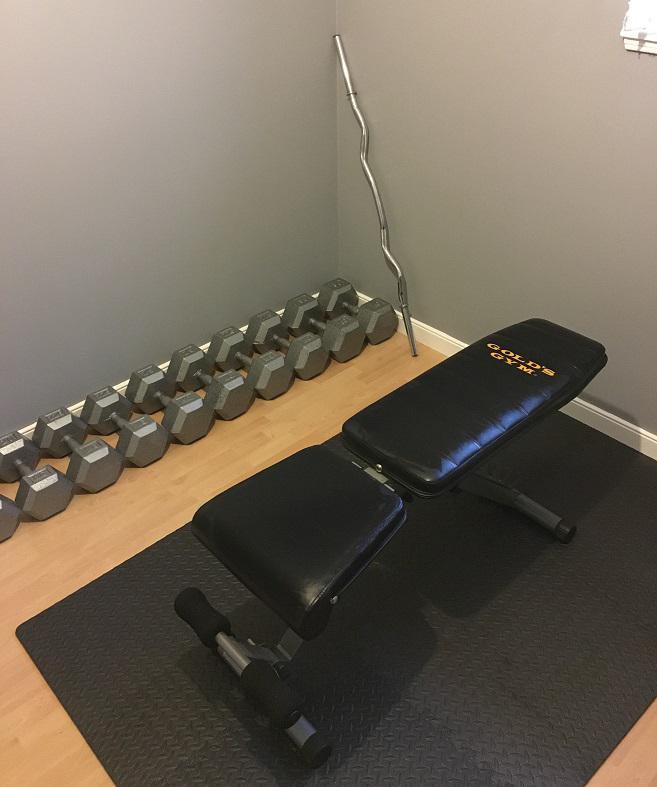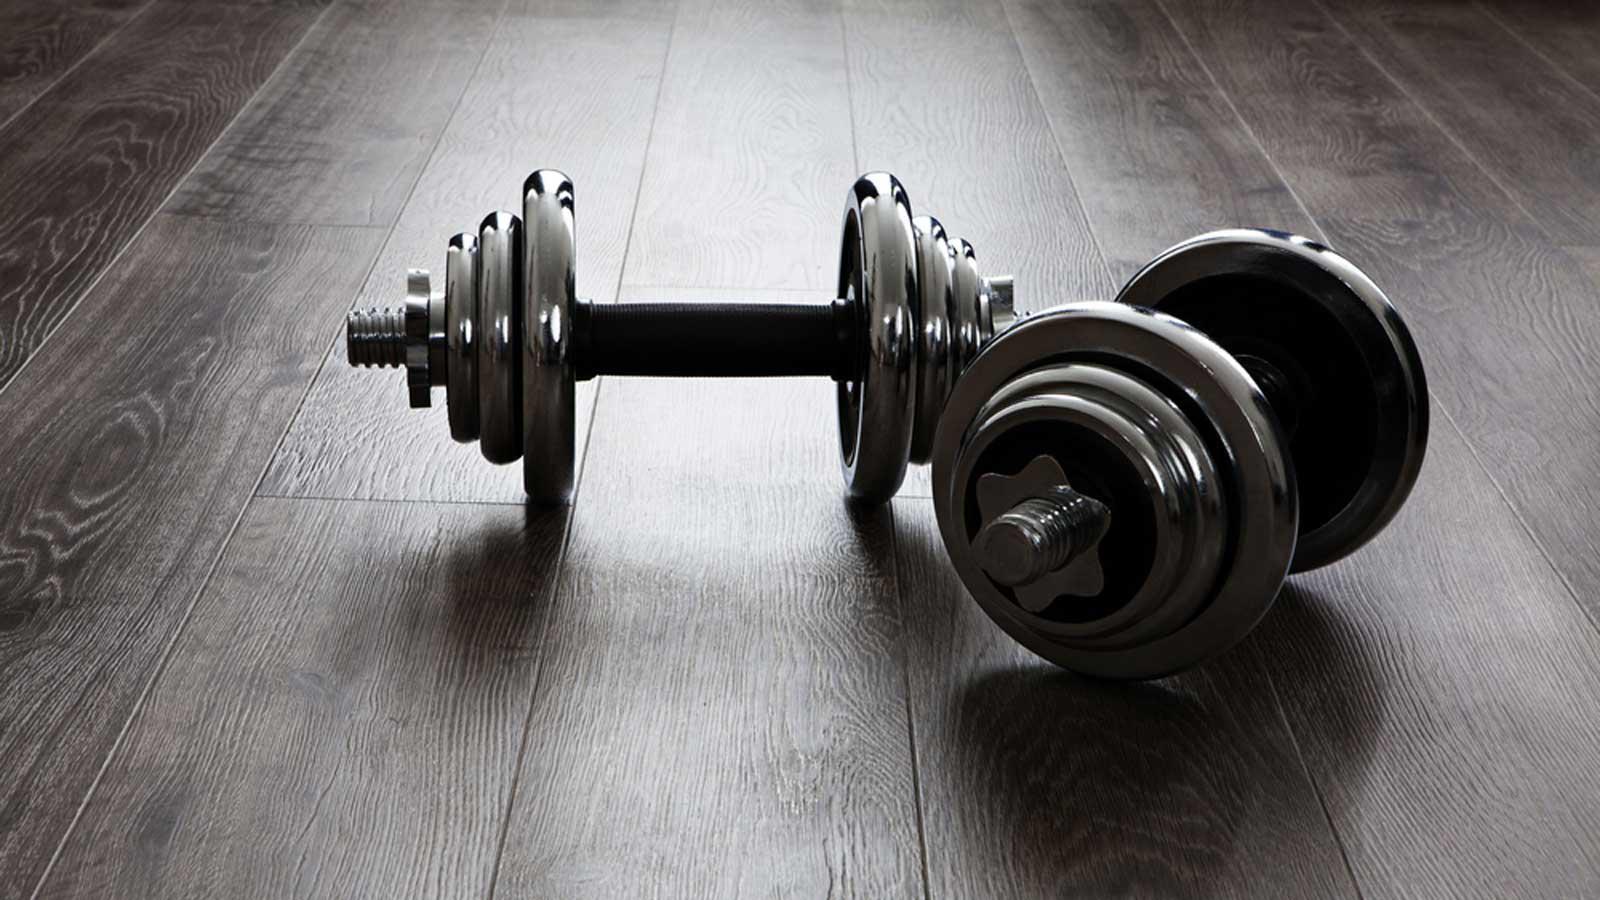The first image is the image on the left, the second image is the image on the right. Evaluate the accuracy of this statement regarding the images: "In at least one image there is a person sitting and working out with weights.". Is it true? Answer yes or no. No. The first image is the image on the left, the second image is the image on the right. Given the left and right images, does the statement "In the image on the left, at least 8 dumbbells are stored against a wall sitting in a straight line." hold true? Answer yes or no. Yes. 